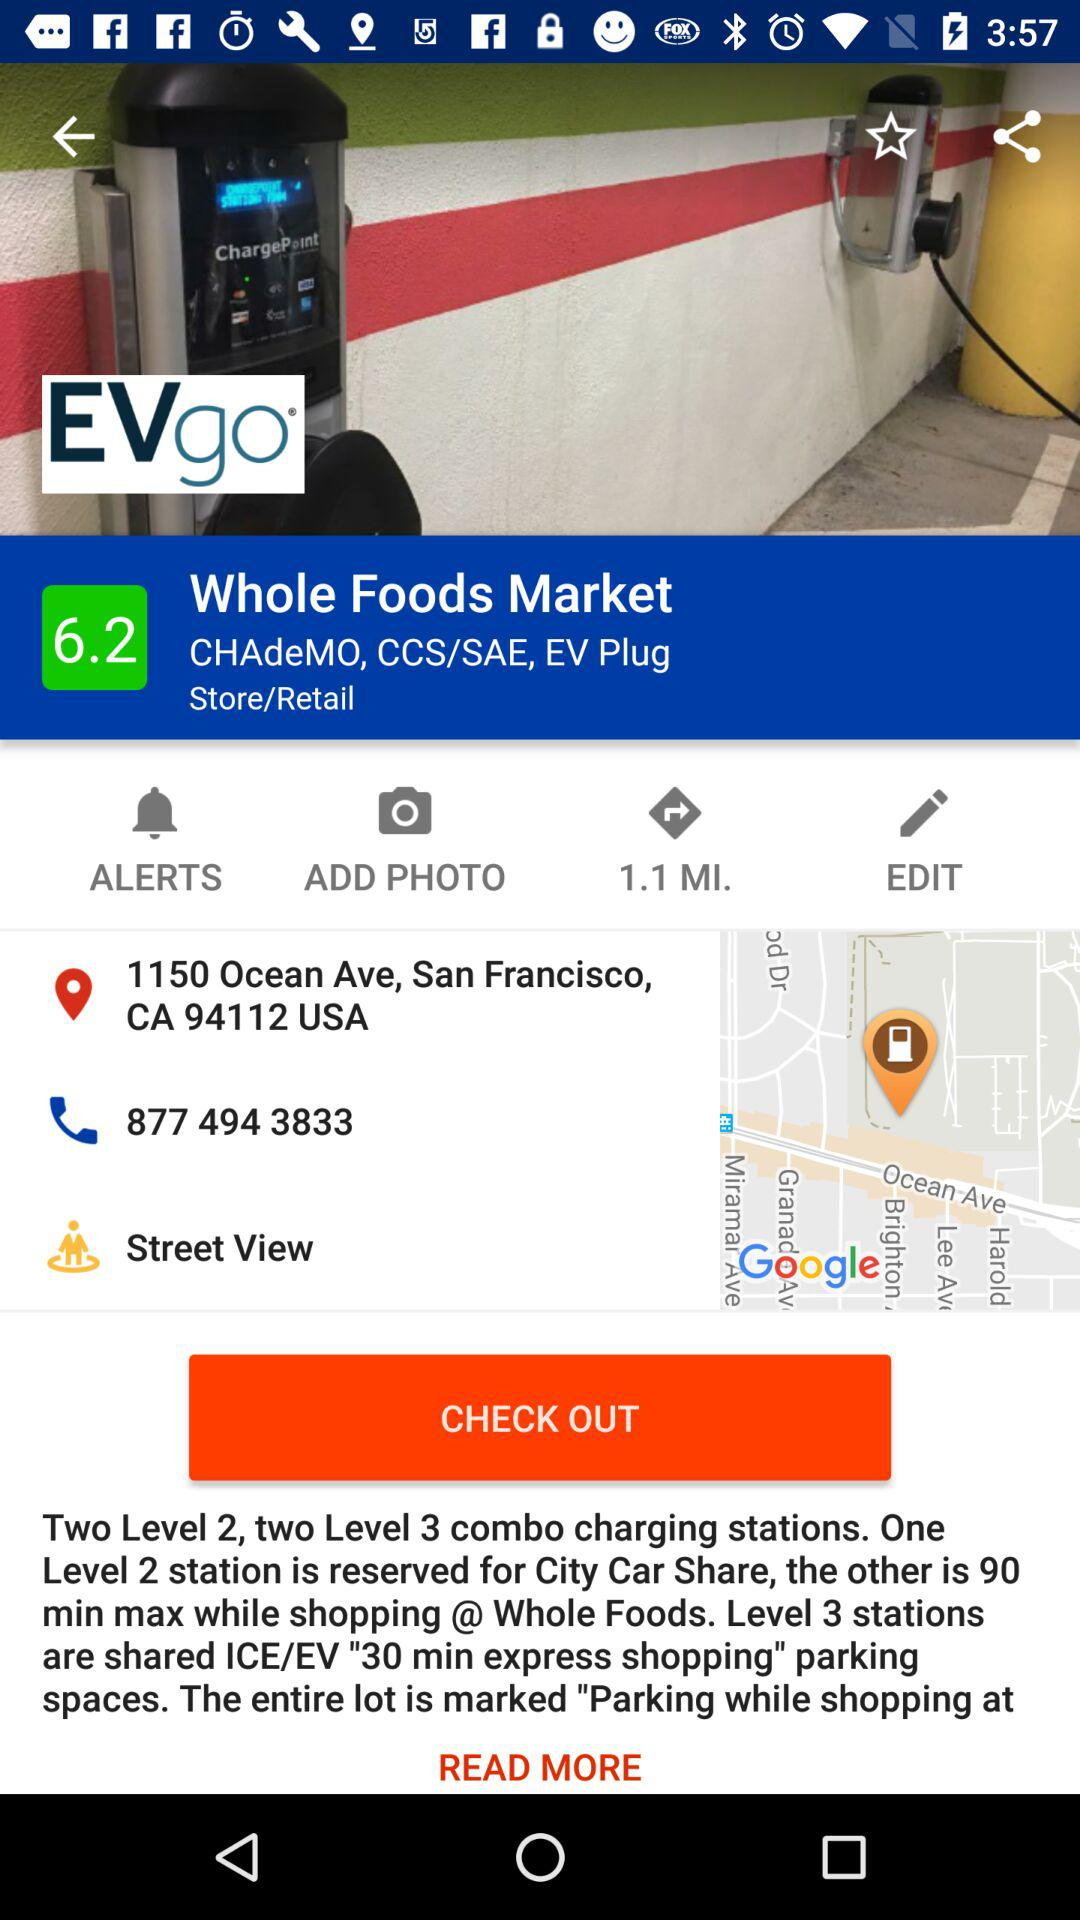What is the phone number? The phone number is 8774943833. 